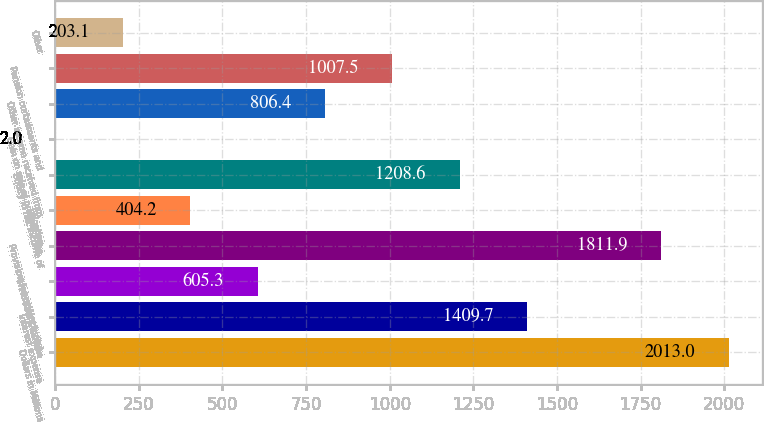Convert chart to OTSL. <chart><loc_0><loc_0><loc_500><loc_500><bar_chart><fcel>Dollars in Millions<fcel>Interest expense<fcel>Investment income<fcel>Provision for restructuring<fcel>Litigation<fcel>Equity in net income of<fcel>Gain on sale of product lines<fcel>Other income received from<fcel>Pension curtailments and<fcel>Other<nl><fcel>2013<fcel>1409.7<fcel>605.3<fcel>1811.9<fcel>404.2<fcel>1208.6<fcel>2<fcel>806.4<fcel>1007.5<fcel>203.1<nl></chart> 